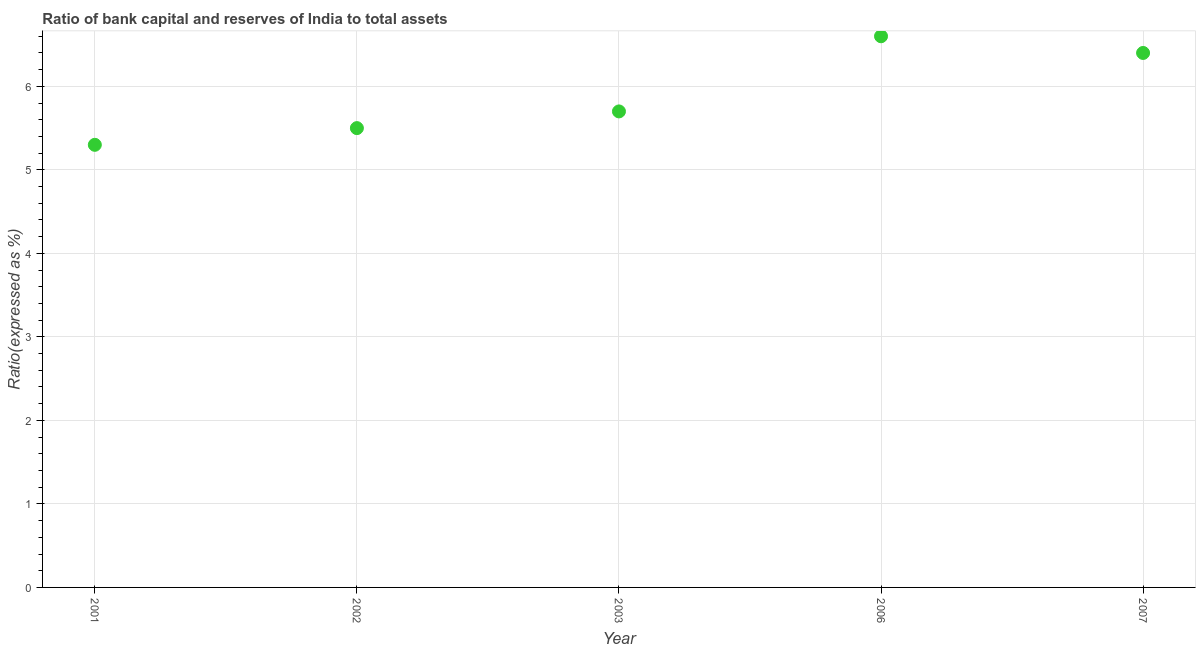What is the bank capital to assets ratio in 2003?
Your response must be concise. 5.7. Across all years, what is the maximum bank capital to assets ratio?
Ensure brevity in your answer.  6.6. In which year was the bank capital to assets ratio maximum?
Your answer should be very brief. 2006. What is the sum of the bank capital to assets ratio?
Provide a succinct answer. 29.5. What is the difference between the bank capital to assets ratio in 2003 and 2006?
Your answer should be very brief. -0.9. What is the average bank capital to assets ratio per year?
Make the answer very short. 5.9. In how many years, is the bank capital to assets ratio greater than 3.2 %?
Provide a short and direct response. 5. What is the ratio of the bank capital to assets ratio in 2002 to that in 2006?
Keep it short and to the point. 0.83. Is the bank capital to assets ratio in 2001 less than that in 2002?
Ensure brevity in your answer.  Yes. What is the difference between the highest and the second highest bank capital to assets ratio?
Offer a very short reply. 0.2. Is the sum of the bank capital to assets ratio in 2006 and 2007 greater than the maximum bank capital to assets ratio across all years?
Your answer should be compact. Yes. What is the difference between the highest and the lowest bank capital to assets ratio?
Your answer should be very brief. 1.3. Does the bank capital to assets ratio monotonically increase over the years?
Provide a short and direct response. No. What is the title of the graph?
Your answer should be very brief. Ratio of bank capital and reserves of India to total assets. What is the label or title of the X-axis?
Your response must be concise. Year. What is the label or title of the Y-axis?
Keep it short and to the point. Ratio(expressed as %). What is the Ratio(expressed as %) in 2001?
Your response must be concise. 5.3. What is the Ratio(expressed as %) in 2006?
Provide a short and direct response. 6.6. What is the Ratio(expressed as %) in 2007?
Ensure brevity in your answer.  6.4. What is the difference between the Ratio(expressed as %) in 2001 and 2002?
Offer a terse response. -0.2. What is the difference between the Ratio(expressed as %) in 2001 and 2006?
Your answer should be very brief. -1.3. What is the difference between the Ratio(expressed as %) in 2002 and 2003?
Make the answer very short. -0.2. What is the difference between the Ratio(expressed as %) in 2002 and 2006?
Offer a terse response. -1.1. What is the difference between the Ratio(expressed as %) in 2003 and 2006?
Offer a terse response. -0.9. What is the ratio of the Ratio(expressed as %) in 2001 to that in 2006?
Give a very brief answer. 0.8. What is the ratio of the Ratio(expressed as %) in 2001 to that in 2007?
Your answer should be very brief. 0.83. What is the ratio of the Ratio(expressed as %) in 2002 to that in 2006?
Your answer should be compact. 0.83. What is the ratio of the Ratio(expressed as %) in 2002 to that in 2007?
Ensure brevity in your answer.  0.86. What is the ratio of the Ratio(expressed as %) in 2003 to that in 2006?
Your answer should be very brief. 0.86. What is the ratio of the Ratio(expressed as %) in 2003 to that in 2007?
Offer a terse response. 0.89. What is the ratio of the Ratio(expressed as %) in 2006 to that in 2007?
Your response must be concise. 1.03. 